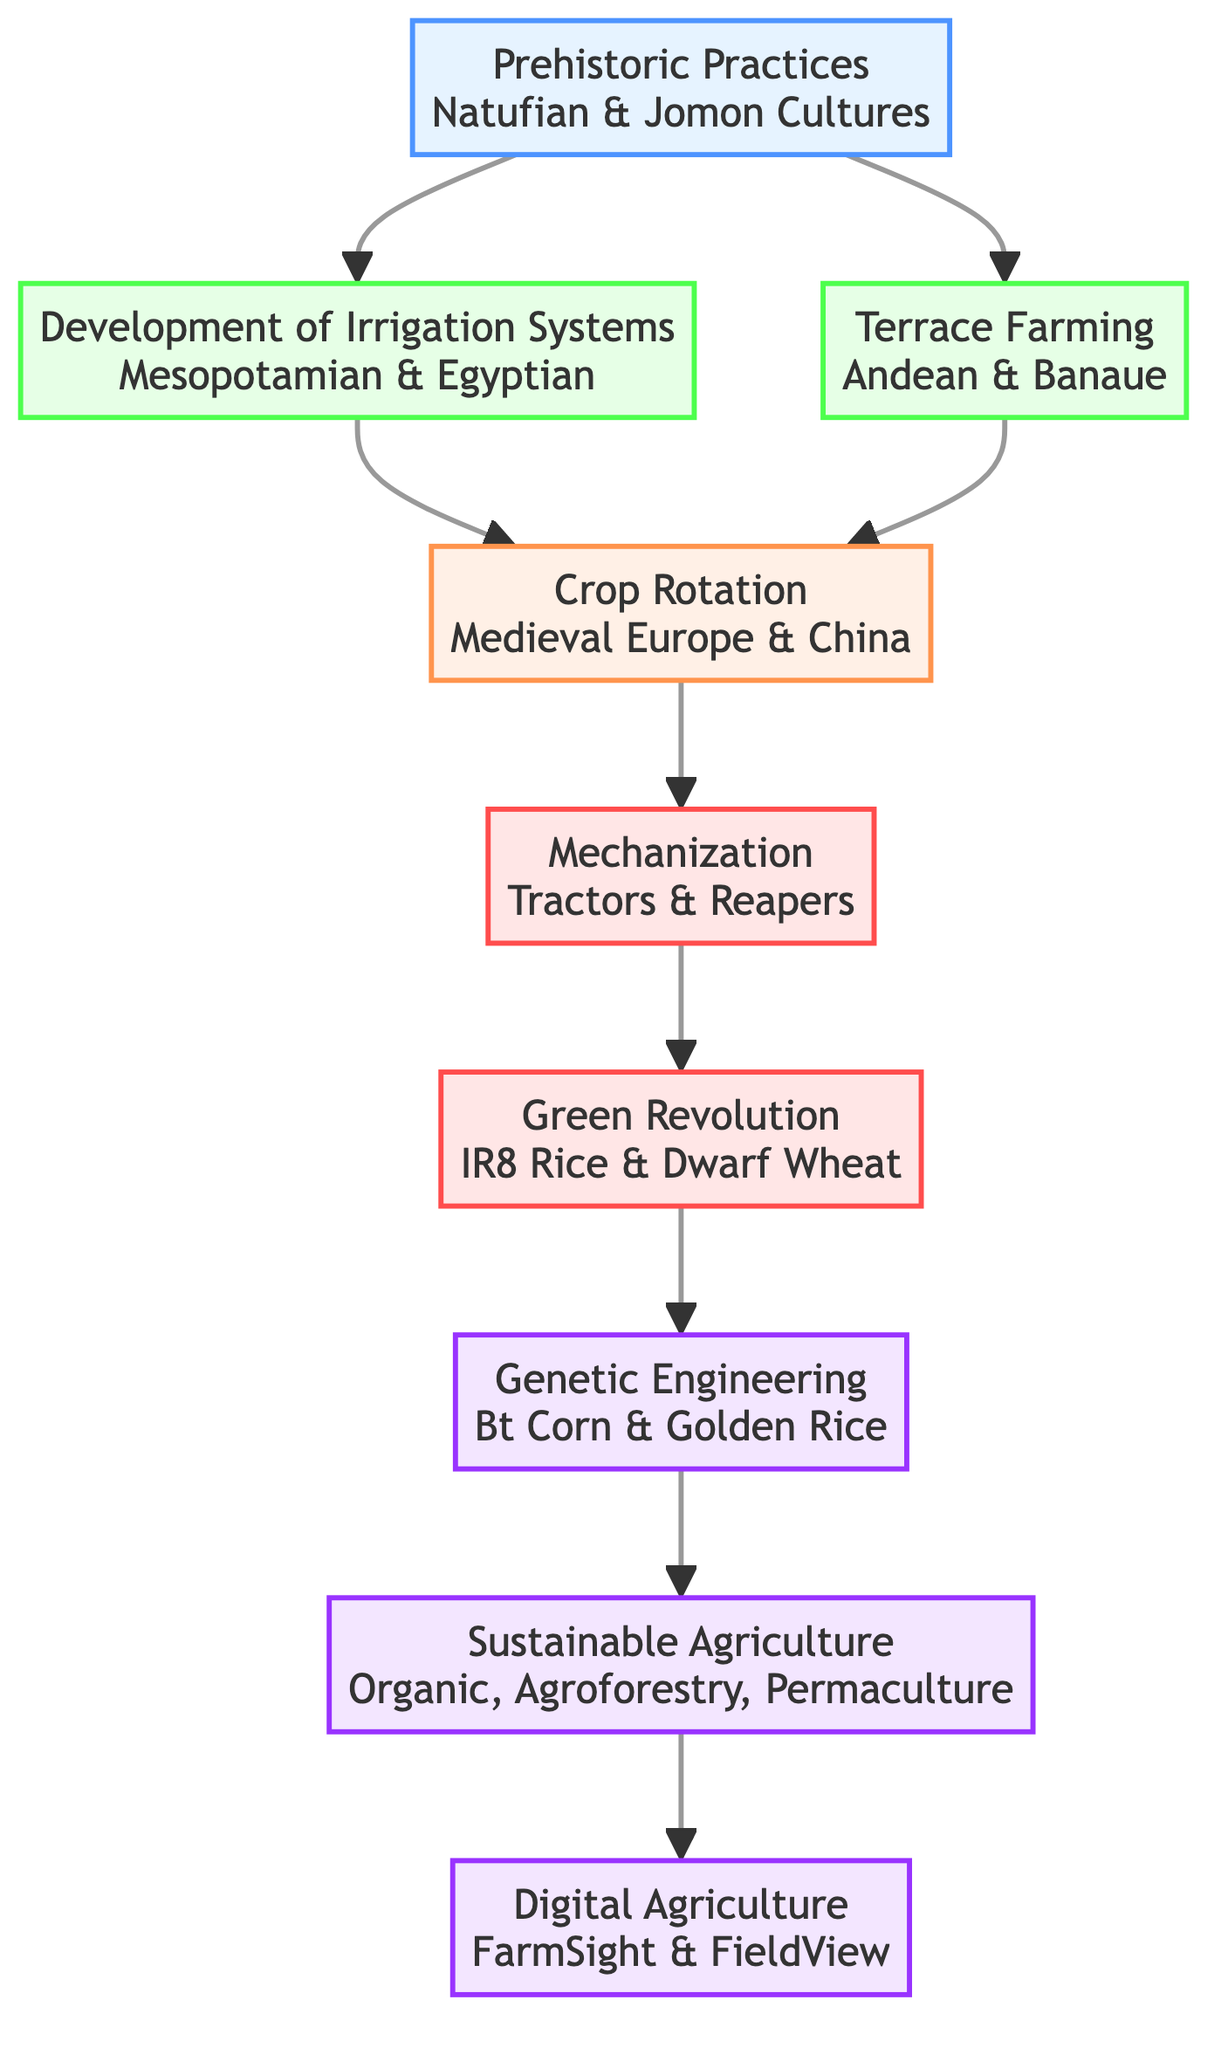What is the first node in the flow chart? The first node in the flow chart represents "Prehistoric Practices," which is the starting point of cultural evolution in agricultural communities.
Answer: Prehistoric Practices How many nodes are there in total? By counting each element listed in the flow chart, including "Prehistoric Practices," "Development of Irrigation Systems," etc., there are a total of 9 nodes.
Answer: 9 What is the last node of this flow chart? The last node in the flow chart is "Digital Agriculture," which showcases the modern advancements in agricultural technology.
Answer: Digital Agriculture Which historical example is associated with Genetic Engineering? The historical example associated with the node "Genetic Engineering" is "Bt Corn," which illustrates a significant development in biotechnology for crops.
Answer: Bt Corn What type of farming technique does "Terrace Farming" represent? "Terrace Farming" represents adaptation of farming techniques to hilly and mountainous terrains, which is noted in the description of the corresponding node.
Answer: Adaptation What connects "Development of Irrigation Systems" to "Crop Rotation and Soil Fertility Management"? The connection is established through a direct link in the flow chart, indicating a progression in techniques from irrigation systems to crop rotation practices.
Answer: Direct link How does "Green Revolution" relate to "Mechanization"? The "Green Revolution" follows "Mechanization," suggesting that advancements in mechanization facilitated the dramatic increase in agricultural production noted during this period.
Answer: Advancement What is the relationship between "Sustainable Agricultural Practices" and "Digital and Precision Agriculture"? "Sustainable Agricultural Practices" lead to "Digital and Precision Agriculture," indicating that environmentally friendly practices are enhanced by modern technologies in agriculture.
Answer: Leads to What is a significant feature of "Crop Rotation and Soil Fertility Management"? A significant feature of "Crop Rotation and Soil Fertility Management" is the practice of rotating crops to maintain soil fertility and prevent soil depletion, as described in its element.
Answer: Rotating crops 